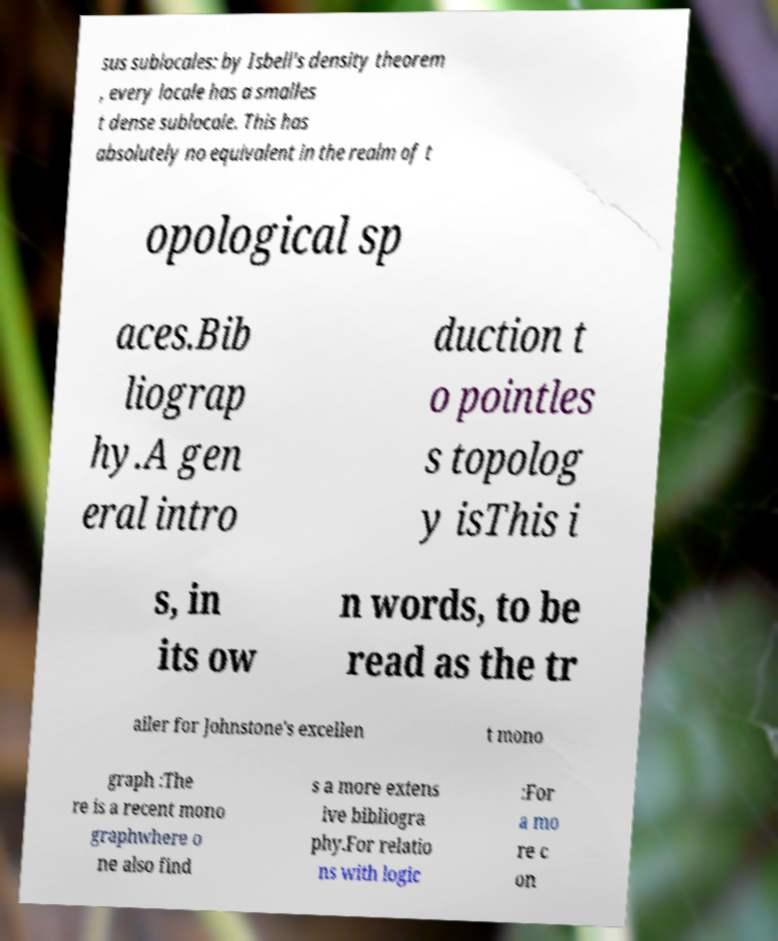Can you read and provide the text displayed in the image?This photo seems to have some interesting text. Can you extract and type it out for me? sus sublocales: by Isbell's density theorem , every locale has a smalles t dense sublocale. This has absolutely no equivalent in the realm of t opological sp aces.Bib liograp hy.A gen eral intro duction t o pointles s topolog y isThis i s, in its ow n words, to be read as the tr ailer for Johnstone's excellen t mono graph :The re is a recent mono graphwhere o ne also find s a more extens ive bibliogra phy.For relatio ns with logic :For a mo re c on 